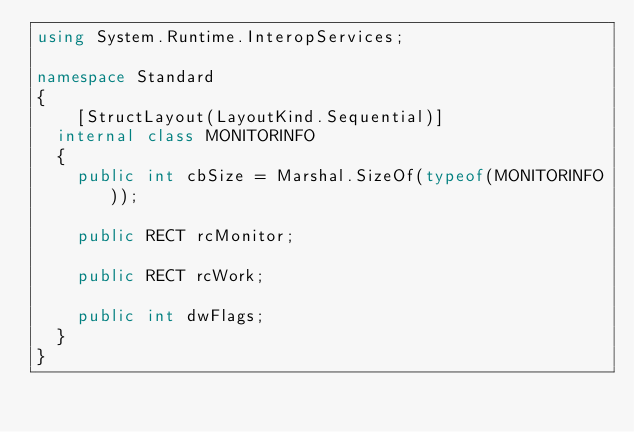<code> <loc_0><loc_0><loc_500><loc_500><_C#_>using System.Runtime.InteropServices;

namespace Standard
{
    [StructLayout(LayoutKind.Sequential)]
	internal class MONITORINFO
	{
		public int cbSize = Marshal.SizeOf(typeof(MONITORINFO));

		public RECT rcMonitor;

		public RECT rcWork;

		public int dwFlags;
	}
}
</code> 